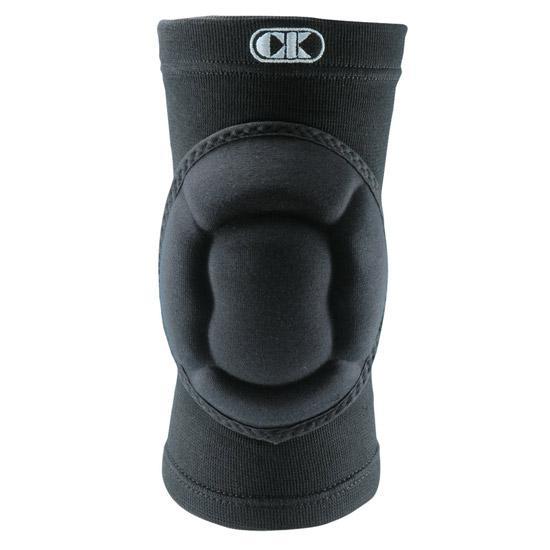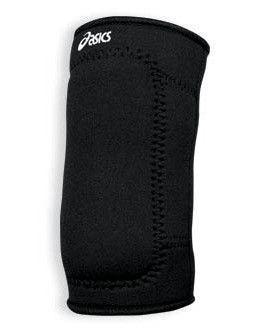The first image is the image on the left, the second image is the image on the right. Evaluate the accuracy of this statement regarding the images: "There are two black knee pads.". Is it true? Answer yes or no. Yes. The first image is the image on the left, the second image is the image on the right. Assess this claim about the two images: "Images each show one knee pad, and pads are turned facing the same direction.". Correct or not? Answer yes or no. No. 